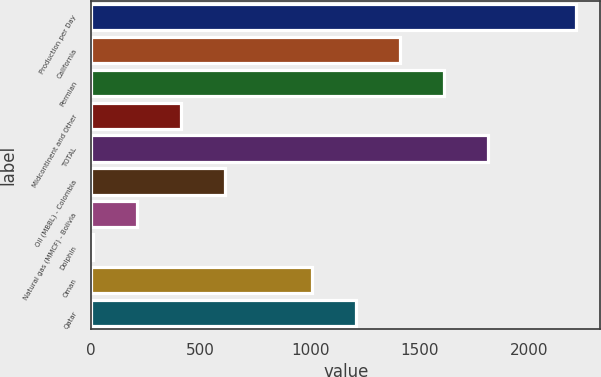<chart> <loc_0><loc_0><loc_500><loc_500><bar_chart><fcel>Production per Day<fcel>California<fcel>Permian<fcel>Midcontinent and Other<fcel>TOTAL<fcel>Oil (MBBL) - Colombia<fcel>Natural gas (MMCF) - Bolivia<fcel>Dolphin<fcel>Oman<fcel>Qatar<nl><fcel>2212.4<fcel>1410.8<fcel>1611.2<fcel>408.8<fcel>1811.6<fcel>609.2<fcel>208.4<fcel>8<fcel>1010<fcel>1210.4<nl></chart> 